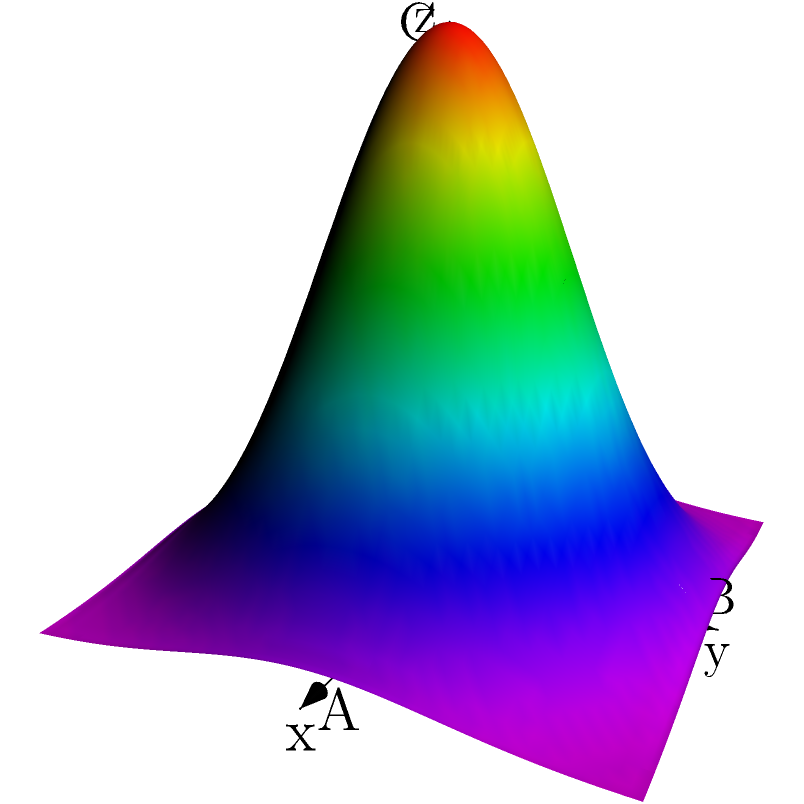In the 3D coordinate system shown above, an irrigation coverage model is represented by the surface $z = 0.5e^{-0.3(x^2+y^2)}$. If point A represents a distance of 3 km along the x-axis, point B represents 3 km along the y-axis, and point C represents 0.5 km along the z-axis, what is the approximate irrigation coverage (in km) at the point (2, 2, z)? To solve this problem, we need to follow these steps:

1) The surface equation is given as $z = 0.5e^{-0.3(x^2+y^2)}$.

2) We need to find the z-value when x = 2 and y = 2.

3) Substituting these values into the equation:

   $z = 0.5e^{-0.3(2^2+2^2)}$
   $z = 0.5e^{-0.3(4+4)}$
   $z = 0.5e^{-0.3(8)}$
   $z = 0.5e^{-2.4}$

4) Calculate this value:
   $z \approx 0.5 * 0.0907 \approx 0.0454$

5) Now, we need to convert this to kilometers. We know that 0.5 on the z-axis represents 0.5 km.

6) So, we can set up a proportion:
   $0.5 : 0.5 \text{ km} = 0.0454 : x \text{ km}$

7) Solving for x:
   $x = \frac{0.0454 * 0.5}{0.5} \approx 0.0454 \text{ km}$

Therefore, the irrigation coverage at the point (2, 2) is approximately 0.0454 km or about 45.4 meters.
Answer: 0.0454 km 